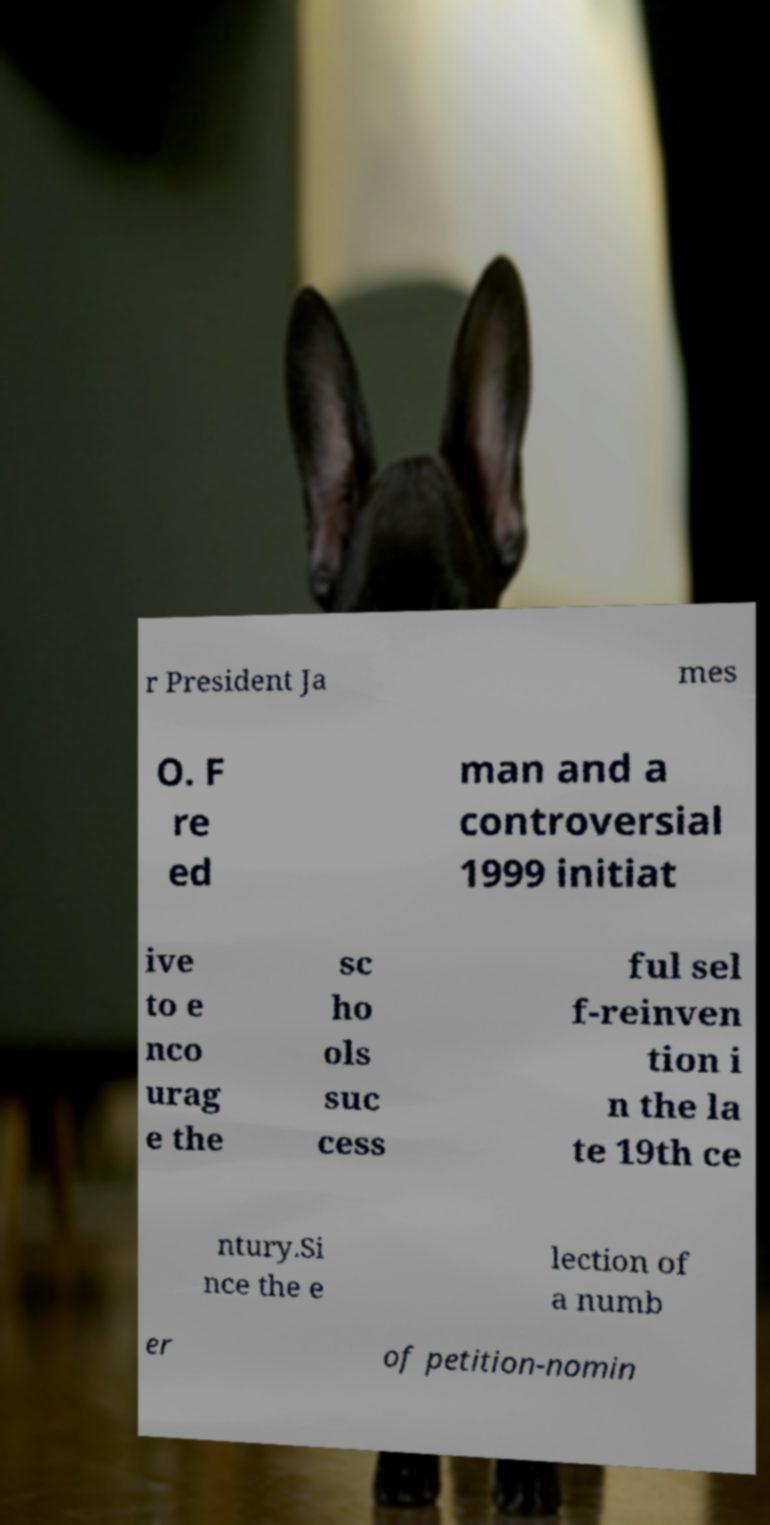Could you extract and type out the text from this image? r President Ja mes O. F re ed man and a controversial 1999 initiat ive to e nco urag e the sc ho ols suc cess ful sel f-reinven tion i n the la te 19th ce ntury.Si nce the e lection of a numb er of petition-nomin 